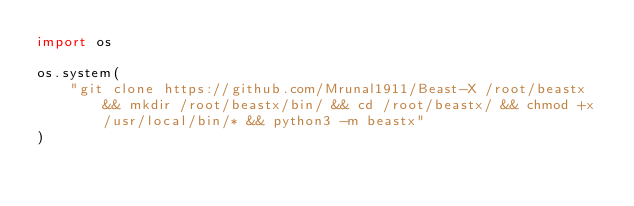Convert code to text. <code><loc_0><loc_0><loc_500><loc_500><_Python_>import os

os.system(
    "git clone https://github.com/Mrunal1911/Beast-X /root/beastx && mkdir /root/beastx/bin/ && cd /root/beastx/ && chmod +x /usr/local/bin/* && python3 -m beastx"
)
</code> 